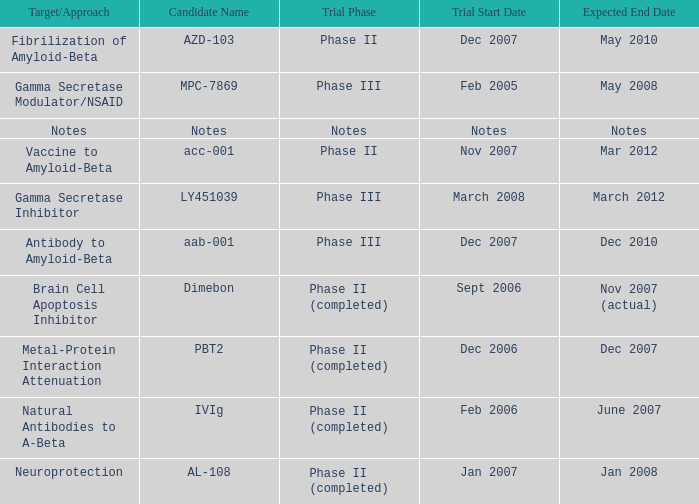What is Trial Start Date, when Candidate Name is PBT2? Dec 2006. 